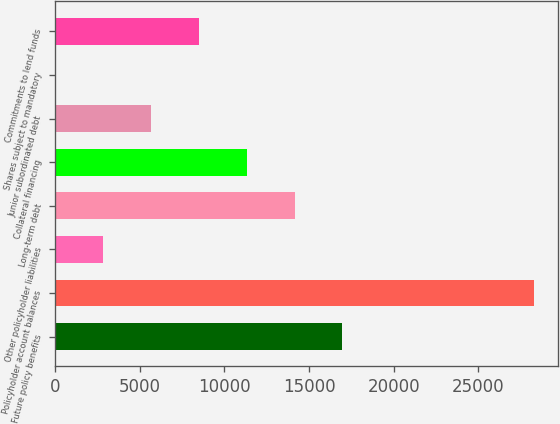Convert chart to OTSL. <chart><loc_0><loc_0><loc_500><loc_500><bar_chart><fcel>Future policy benefits<fcel>Policyholder account balances<fcel>Other policyholder liabilities<fcel>Long-term debt<fcel>Collateral financing<fcel>Junior subordinated debt<fcel>Shares subject to mandatory<fcel>Commitments to lend funds<nl><fcel>16977.2<fcel>28278<fcel>2851.2<fcel>14152<fcel>11326.8<fcel>5676.4<fcel>26<fcel>8501.6<nl></chart> 